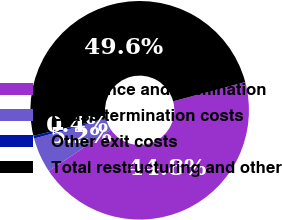Convert chart. <chart><loc_0><loc_0><loc_500><loc_500><pie_chart><fcel>Severance and termination<fcel>Lease termination costs<fcel>Other exit costs<fcel>Total restructuring and other<nl><fcel>44.78%<fcel>5.22%<fcel>0.4%<fcel>49.6%<nl></chart> 